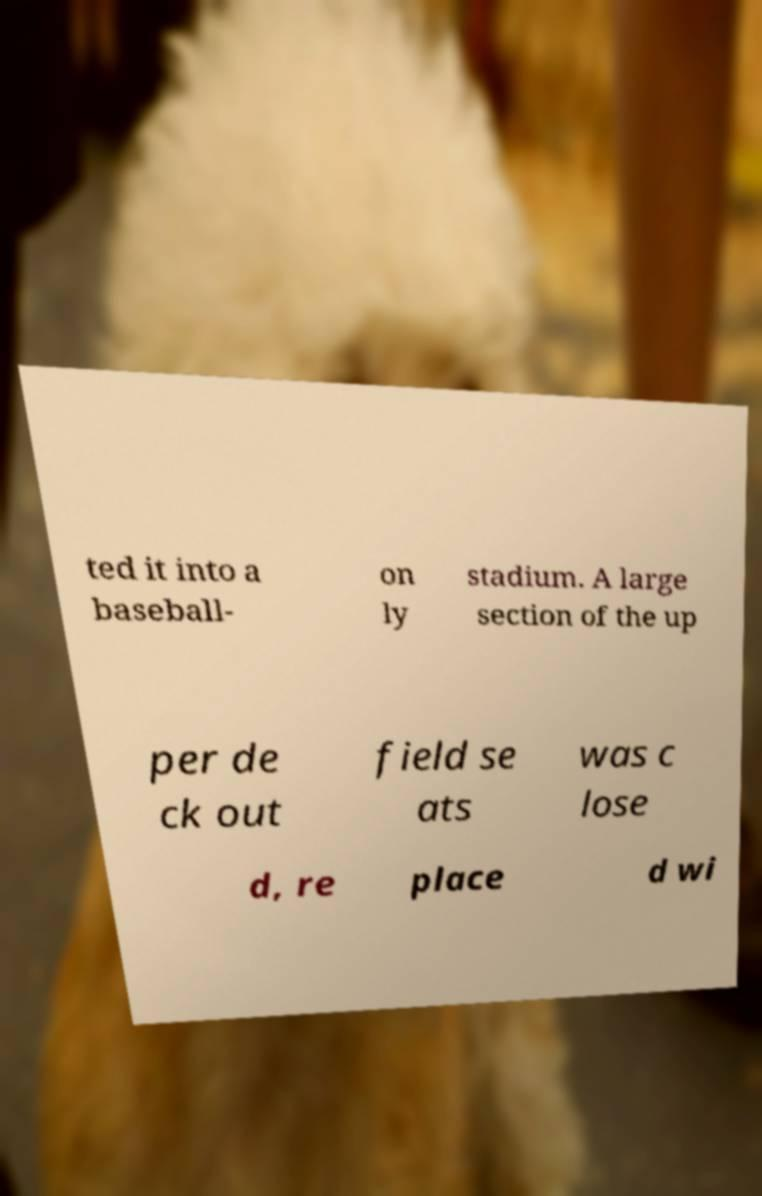Could you assist in decoding the text presented in this image and type it out clearly? ted it into a baseball- on ly stadium. A large section of the up per de ck out field se ats was c lose d, re place d wi 